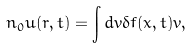Convert formula to latex. <formula><loc_0><loc_0><loc_500><loc_500>n _ { 0 } { u } ( { r } , t ) = \int d { v } \delta f ( { x } , t ) { v } ,</formula> 